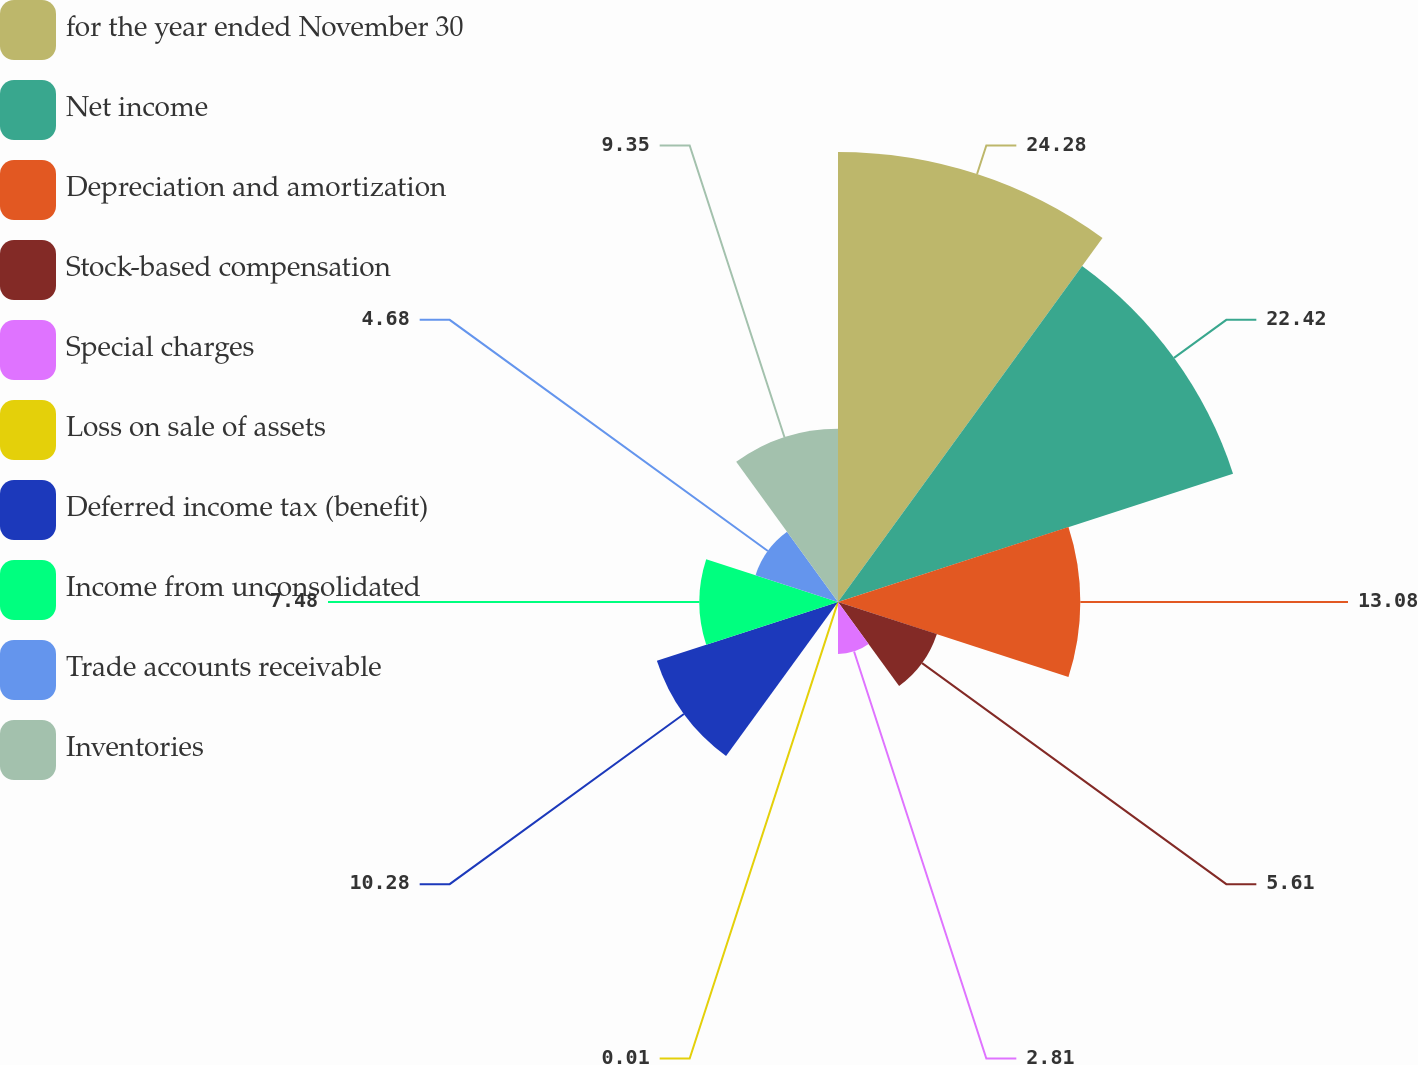Convert chart to OTSL. <chart><loc_0><loc_0><loc_500><loc_500><pie_chart><fcel>for the year ended November 30<fcel>Net income<fcel>Depreciation and amortization<fcel>Stock-based compensation<fcel>Special charges<fcel>Loss on sale of assets<fcel>Deferred income tax (benefit)<fcel>Income from unconsolidated<fcel>Trade accounts receivable<fcel>Inventories<nl><fcel>24.29%<fcel>22.42%<fcel>13.08%<fcel>5.61%<fcel>2.81%<fcel>0.01%<fcel>10.28%<fcel>7.48%<fcel>4.68%<fcel>9.35%<nl></chart> 